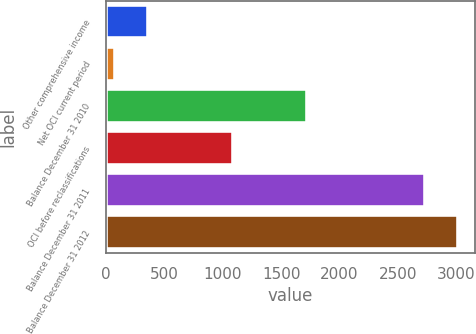<chart> <loc_0><loc_0><loc_500><loc_500><bar_chart><fcel>Other comprehensive income<fcel>Net OCI current period<fcel>Balance December 31 2010<fcel>OCI before reclassifications<fcel>Balance December 31 2011<fcel>Balance December 31 2012<nl><fcel>360.1<fcel>77<fcel>1719<fcel>1091<fcel>2729<fcel>3012.1<nl></chart> 